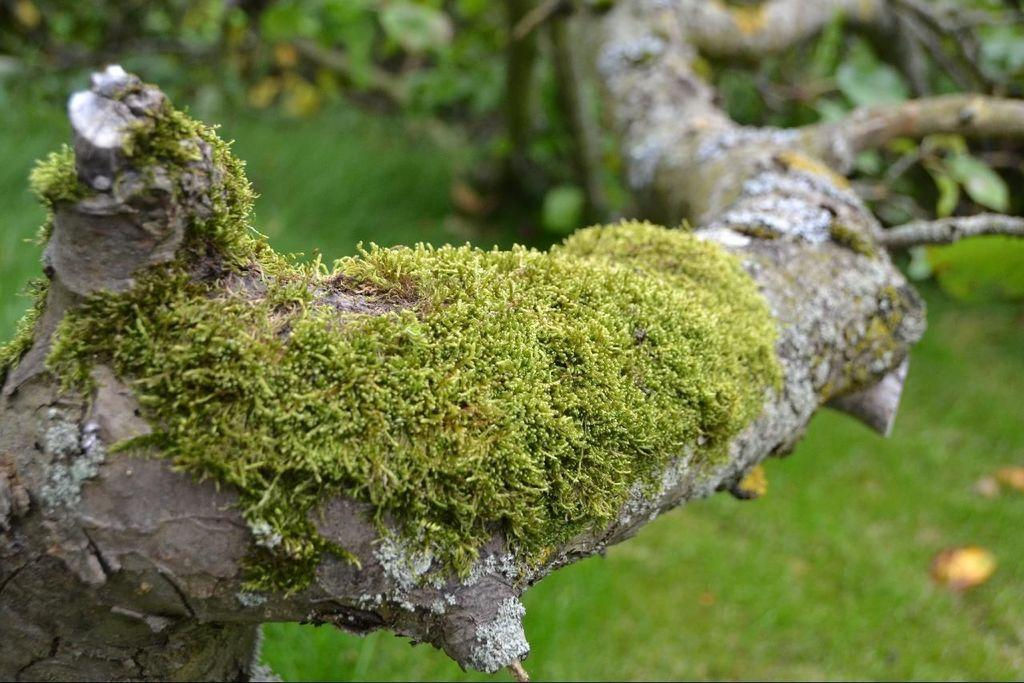What type of vegetation can be seen in the image? There are trees in the image. What is covering the ground in the image? There is grass on the ground in the image. What type of bell can be seen hanging from the tree in the image? There is no bell present in the image; it only features trees and grass. Is there a bed visible in the image? No, there is no bed present in the image. 